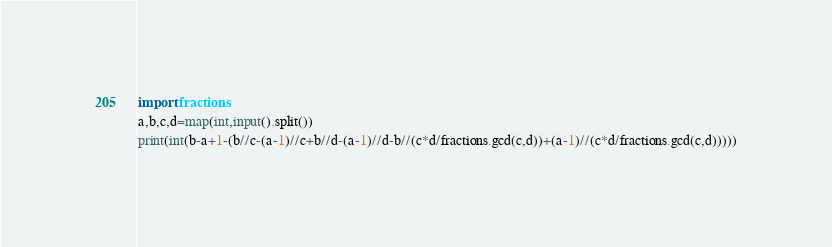Convert code to text. <code><loc_0><loc_0><loc_500><loc_500><_Python_>import fractions
a,b,c,d=map(int,input().split())
print(int(b-a+1-(b//c-(a-1)//c+b//d-(a-1)//d-b//(c*d/fractions.gcd(c,d))+(a-1)//(c*d/fractions.gcd(c,d)))))
</code> 